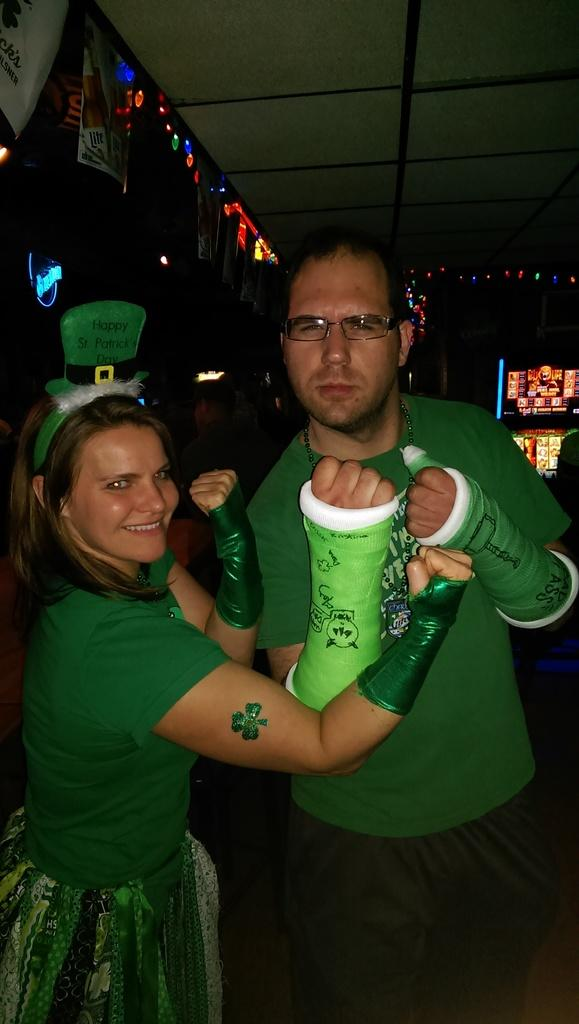How many people are in the image? There are two people in the image, a man and a woman. What are the man and the woman wearing? Both the man and the woman are wearing green dresses. What can be seen on the wall in the background? There are posters on the wall in the background. What type of lighting is present in the background? There are lights in the background. What is visible at the top of the image? There is a roof visible at the top of the image. What type of parcel is being delivered to the man in the image? There is no parcel being delivered to the man in the image. What color is the underwear worn by the woman in the image? The image does not show the woman's underwear, so we cannot determine its color. 